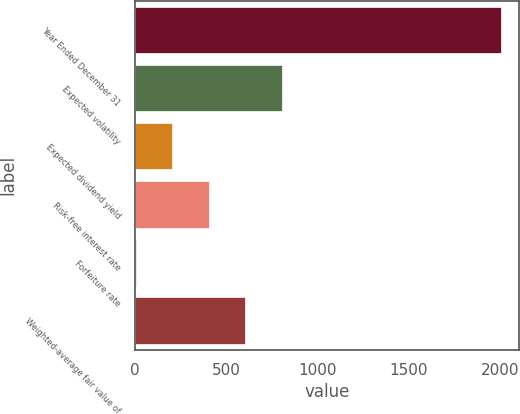Convert chart. <chart><loc_0><loc_0><loc_500><loc_500><bar_chart><fcel>Year Ended December 31<fcel>Expected volatility<fcel>Expected dividend yield<fcel>Risk-free interest rate<fcel>Forfeiture rate<fcel>Weighted-average fair value of<nl><fcel>2006<fcel>805.16<fcel>204.74<fcel>404.88<fcel>4.6<fcel>605.02<nl></chart> 